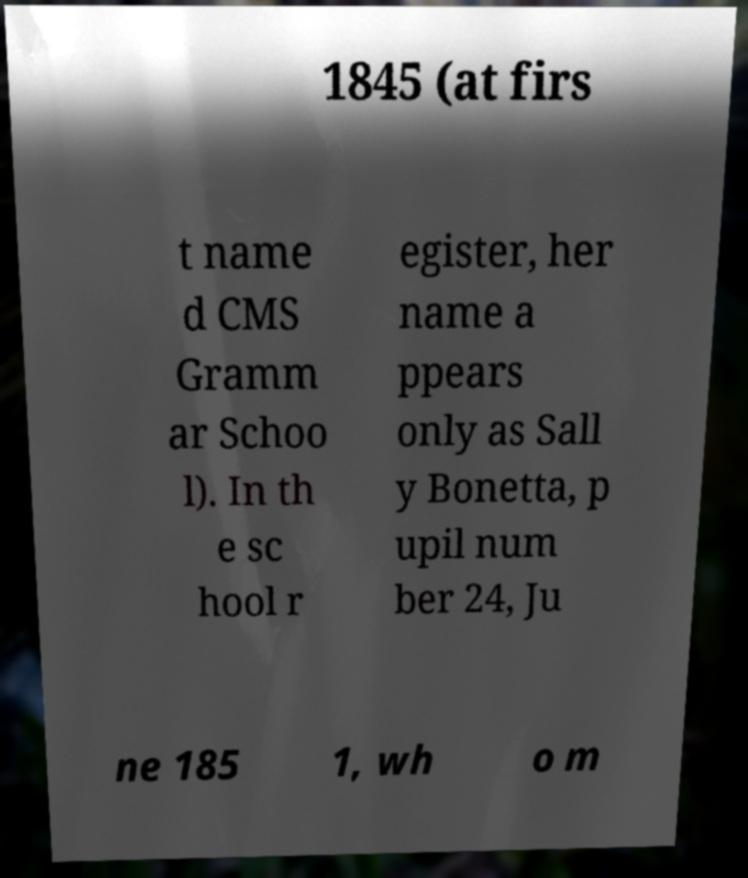I need the written content from this picture converted into text. Can you do that? 1845 (at firs t name d CMS Gramm ar Schoo l). In th e sc hool r egister, her name a ppears only as Sall y Bonetta, p upil num ber 24, Ju ne 185 1, wh o m 